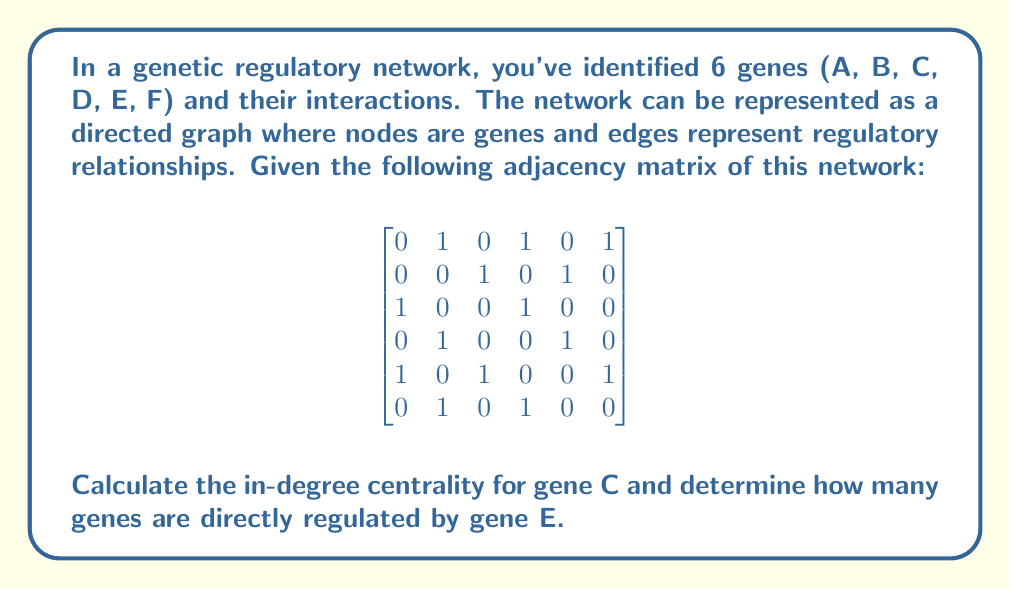Can you solve this math problem? To solve this problem, we need to understand the concepts of adjacency matrix and in-degree centrality in graph theory, and how they apply to genetic regulatory networks.

1. Adjacency Matrix:
   In the given matrix, rows and columns represent genes A, B, C, D, E, F in order. A value of 1 in cell (i,j) indicates that gene i regulates gene j.

2. In-degree Centrality:
   The in-degree centrality of a node (gene) is the number of incoming edges (regulatory relationships) to that node. In the adjacency matrix, this is represented by the number of 1's in the column corresponding to that gene.

3. Calculating in-degree centrality for gene C:
   Gene C corresponds to the 3rd column in the matrix. We count the number of 1's in this column:
   $$\begin{bmatrix} 0 \\ 1 \\ 0 \\ 0 \\ 1 \\ 0 \end{bmatrix}$$
   There are two 1's, so the in-degree centrality of gene C is 2.

4. Determining genes directly regulated by gene E:
   Gene E corresponds to the 5th row in the matrix. We count the number of 1's in this row:
   $$\begin{bmatrix} 1 & 0 & 1 & 0 & 0 & 1 \end{bmatrix}$$
   There are three 1's, indicating that gene E directly regulates 3 genes.
Answer: The in-degree centrality of gene C is 2, and gene E directly regulates 3 genes. 